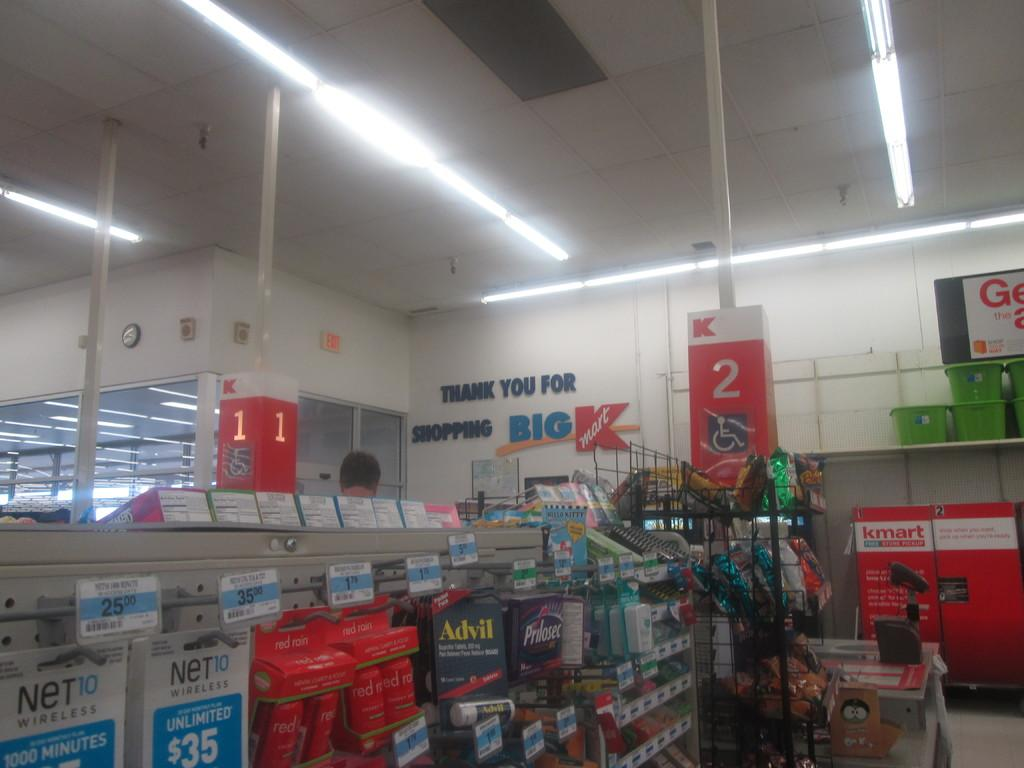<image>
Render a clear and concise summary of the photo. an isle inside of big kmart with the number 2 on it 